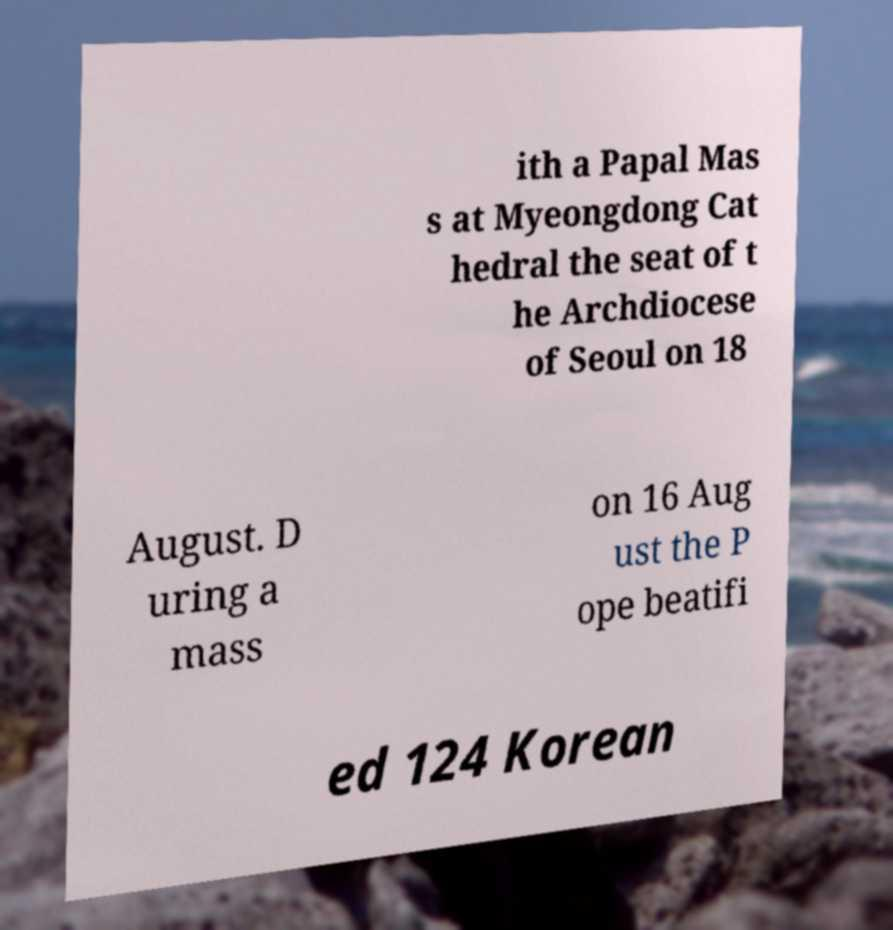I need the written content from this picture converted into text. Can you do that? ith a Papal Mas s at Myeongdong Cat hedral the seat of t he Archdiocese of Seoul on 18 August. D uring a mass on 16 Aug ust the P ope beatifi ed 124 Korean 